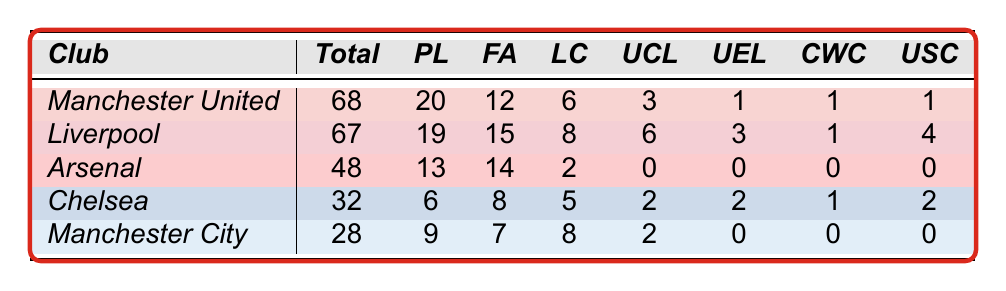What is the total number of trophies won by Manchester United? According to the table, under the "Total" column, the number of trophies won by Manchester United is listed as 68.
Answer: 68 How many Premier League titles has Liverpool won? In the table, Liverpool's Premier League titles are found under the "PL" column, which shows a value of 19.
Answer: 19 Which club has won more FA Cups, Manchester United or Arsenal? Manchester United's FA Cup wins are listed as 12, while Arsenal's are 14. Since 14 is greater than 12, Arsenal has more FA Cups than Manchester United.
Answer: Arsenal What is the difference between the total trophies won by Manchester United and Liverpool? Manchester United has won 68 trophies and Liverpool has won 67. The difference is 68 - 67 = 1.
Answer: 1 Which club has the least number of trophies won? By checking the "Total" column, Chelsea has won 32 trophies, while Manchester City has won 28 trophies, which is the least among the clubs shown in the table.
Answer: Manchester City How many UEFA Champions League titles have Manchester City won compared to Chelsea? Manchester City has won 2 UEFA Champions League titles, while Chelsea has also won 2, according to the "UCL" column. Therefore, they have an equal number of titles.
Answer: Equal What is the combined number of trophies won by Arsenal and Chelsea? Arsenal has won 48 trophies and Chelsea has won 32 trophies. The combination is 48 + 32 = 80.
Answer: 80 If you combine the League Cup wins of Manchester United and Liverpool, how many do you get? Manchester United has won 6 League Cups and Liverpool has won 8. Adding these gives 6 + 8 = 14.
Answer: 14 Is it true that Arsenal has won at least one UEFA Champions League title? According to the table, Arsenal has won 0 UEFA Champions League titles, so the statement is false.
Answer: False Who has the most trophies won in total among the clubs listed? By comparing the total trophies won, Manchester United has 68, while Liverpool has 67. Thus, Manchester United has the most trophies among the listed clubs.
Answer: Manchester United 